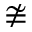Convert formula to latex. <formula><loc_0><loc_0><loc_500><loc_500>\ncong</formula> 